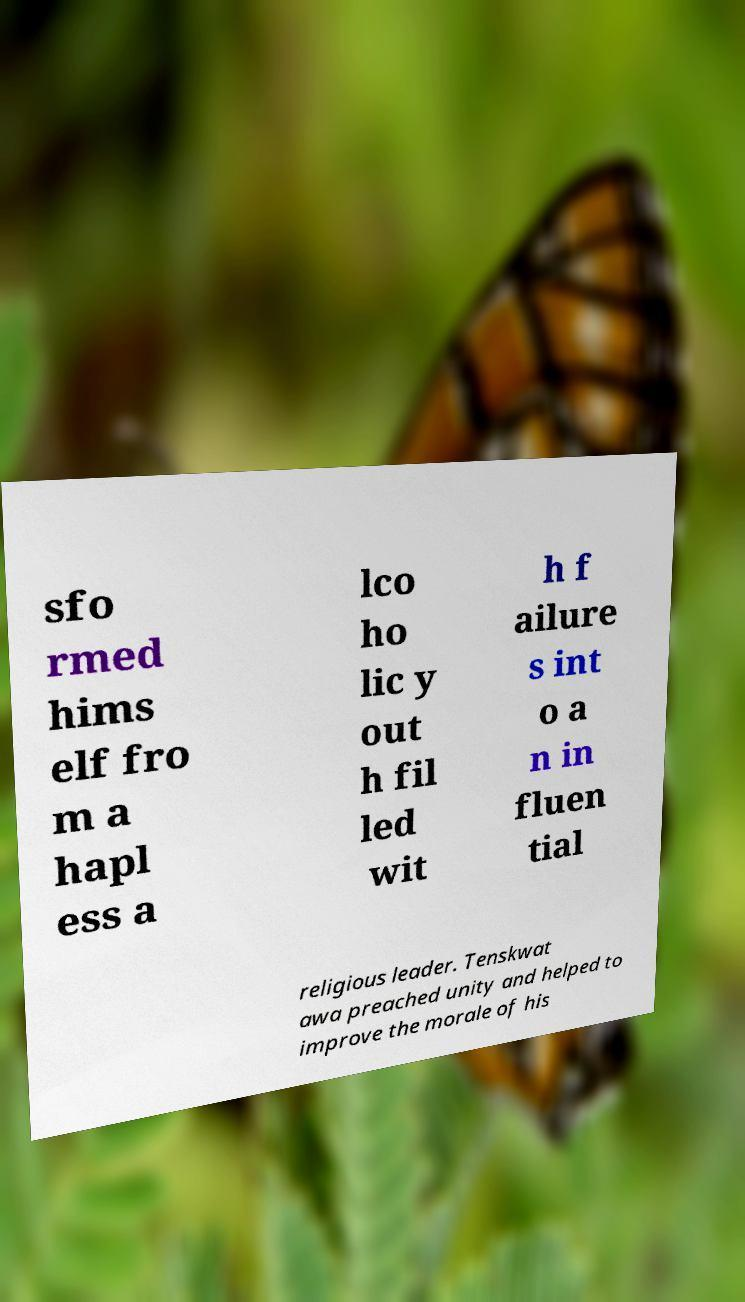Could you assist in decoding the text presented in this image and type it out clearly? sfo rmed hims elf fro m a hapl ess a lco ho lic y out h fil led wit h f ailure s int o a n in fluen tial religious leader. Tenskwat awa preached unity and helped to improve the morale of his 